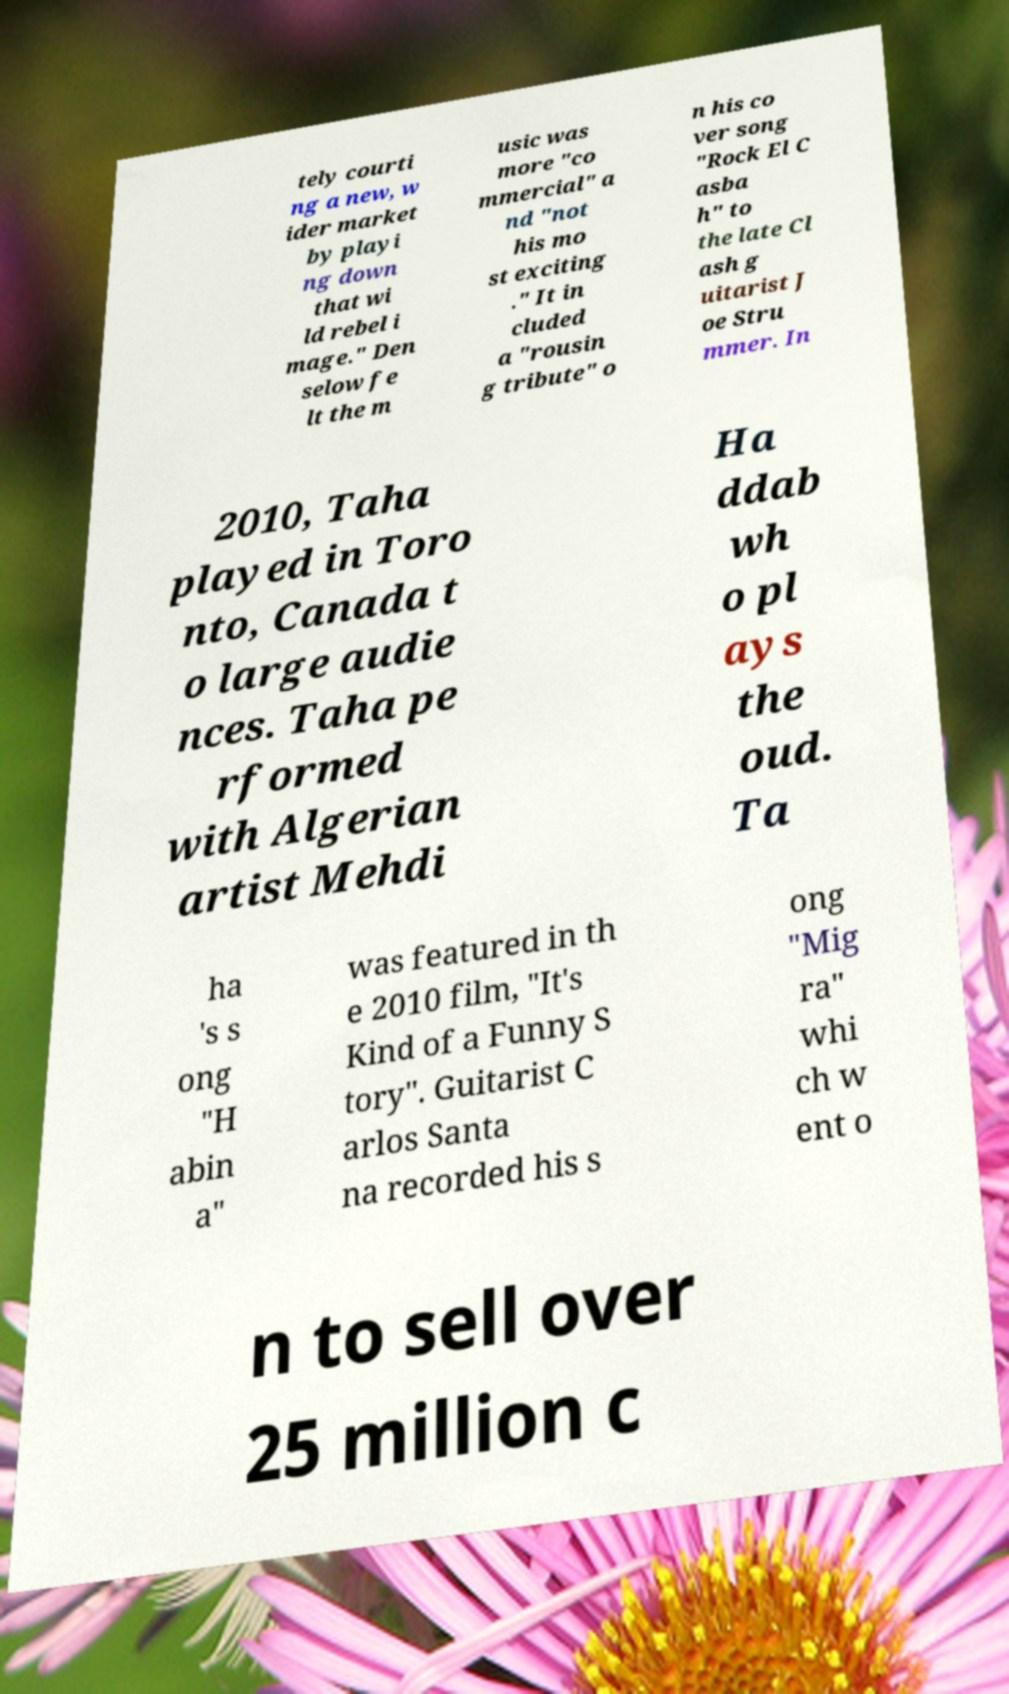Please read and relay the text visible in this image. What does it say? tely courti ng a new, w ider market by playi ng down that wi ld rebel i mage." Den selow fe lt the m usic was more "co mmercial" a nd "not his mo st exciting ." It in cluded a "rousin g tribute" o n his co ver song "Rock El C asba h" to the late Cl ash g uitarist J oe Stru mmer. In 2010, Taha played in Toro nto, Canada t o large audie nces. Taha pe rformed with Algerian artist Mehdi Ha ddab wh o pl ays the oud. Ta ha 's s ong "H abin a" was featured in th e 2010 film, "It's Kind of a Funny S tory". Guitarist C arlos Santa na recorded his s ong "Mig ra" whi ch w ent o n to sell over 25 million c 